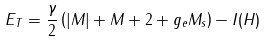Convert formula to latex. <formula><loc_0><loc_0><loc_500><loc_500>E _ { T } = \frac { \gamma } { 2 } \left ( | M | + M + 2 + g _ { e } M _ { s } \right ) - I ( H )</formula> 